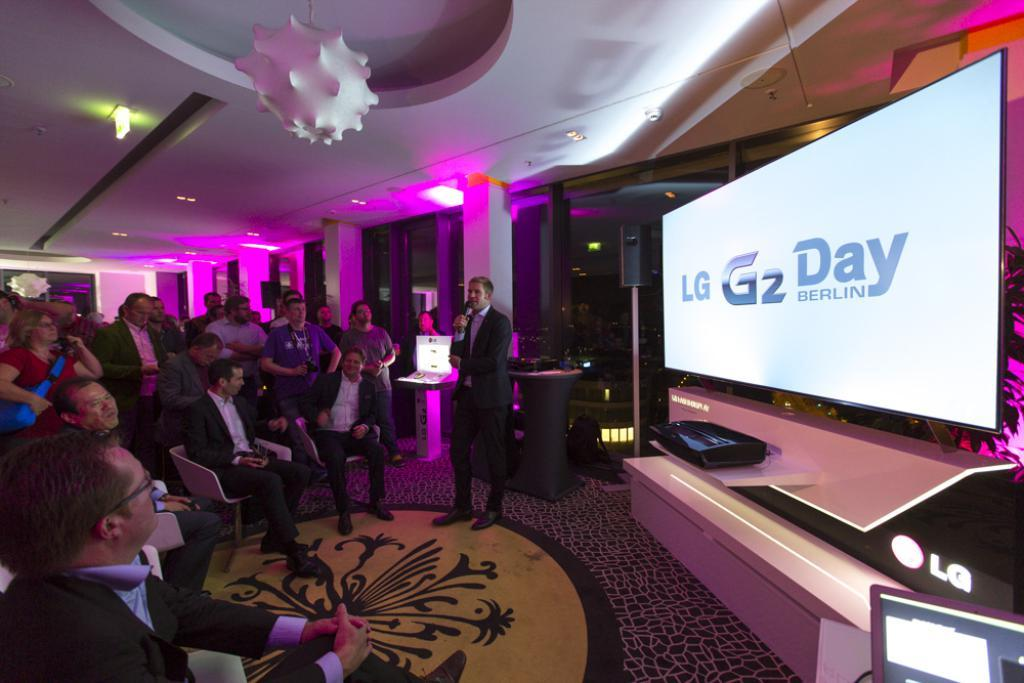What is happening on the left side of the image? There is a group of people sitting in chairs on the left side of the image. Can you describe the man in the image? There is a man standing in the image. What can be inferred about the man's clothing? The man is wearing a (unspecified) type of clothing. How many spiders are sitting on the man's lace clothing in the image? There are no spiders or lace clothing present in the image. Are the people sitting in the chairs friends with the man standing in the image? The image does not provide information about the relationships between the people, so we cannot determine if they are friends or not. 